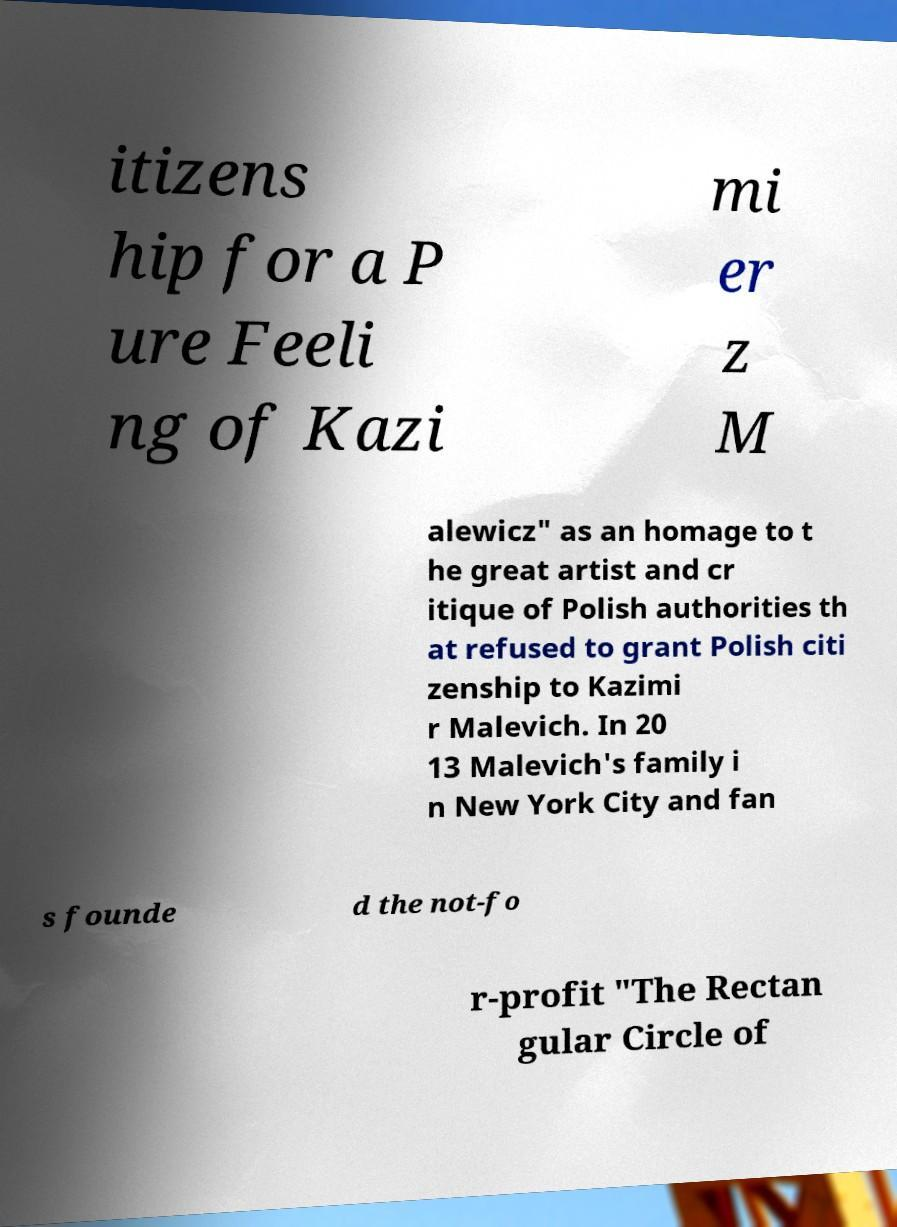Can you accurately transcribe the text from the provided image for me? itizens hip for a P ure Feeli ng of Kazi mi er z M alewicz" as an homage to t he great artist and cr itique of Polish authorities th at refused to grant Polish citi zenship to Kazimi r Malevich. In 20 13 Malevich's family i n New York City and fan s founde d the not-fo r-profit "The Rectan gular Circle of 